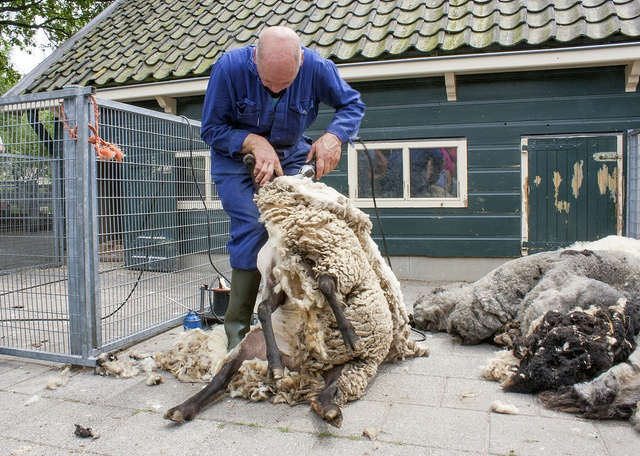Describe the objects in this image and their specific colors. I can see sheep in black, gray, lightgray, darkgray, and tan tones and people in black, navy, blue, and lightpink tones in this image. 